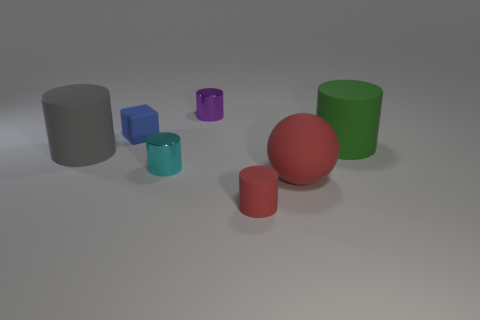Is there a cyan shiny cylinder that is in front of the rubber ball in front of the small cyan cylinder?
Your answer should be very brief. No. There is a metallic thing that is behind the large green matte cylinder; is its shape the same as the red object to the right of the small red matte cylinder?
Your answer should be very brief. No. Is the material of the big cylinder that is on the right side of the purple shiny thing the same as the small object in front of the big red matte sphere?
Provide a short and direct response. Yes. What material is the small cylinder that is behind the small shiny thing that is in front of the small purple cylinder?
Provide a succinct answer. Metal. What is the shape of the tiny matte thing that is in front of the big matte cylinder that is right of the tiny shiny cylinder behind the gray matte object?
Provide a short and direct response. Cylinder. There is a gray object that is the same shape as the green matte thing; what material is it?
Make the answer very short. Rubber. How many red spheres are there?
Provide a succinct answer. 1. What is the shape of the metal thing that is in front of the purple shiny cylinder?
Offer a terse response. Cylinder. There is a tiny metal cylinder in front of the big rubber cylinder that is on the right side of the cylinder behind the large green cylinder; what color is it?
Keep it short and to the point. Cyan. What shape is the cyan thing that is the same material as the small purple cylinder?
Your answer should be compact. Cylinder. 